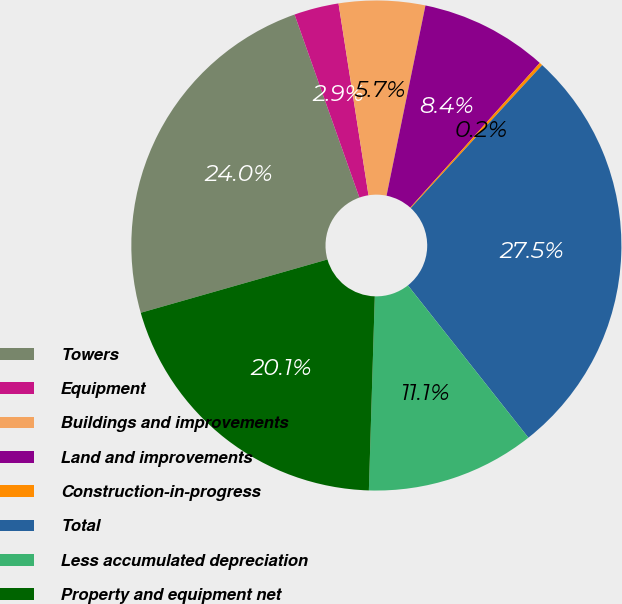<chart> <loc_0><loc_0><loc_500><loc_500><pie_chart><fcel>Towers<fcel>Equipment<fcel>Buildings and improvements<fcel>Land and improvements<fcel>Construction-in-progress<fcel>Total<fcel>Less accumulated depreciation<fcel>Property and equipment net<nl><fcel>24.01%<fcel>2.95%<fcel>5.68%<fcel>8.41%<fcel>0.21%<fcel>27.52%<fcel>11.14%<fcel>20.09%<nl></chart> 